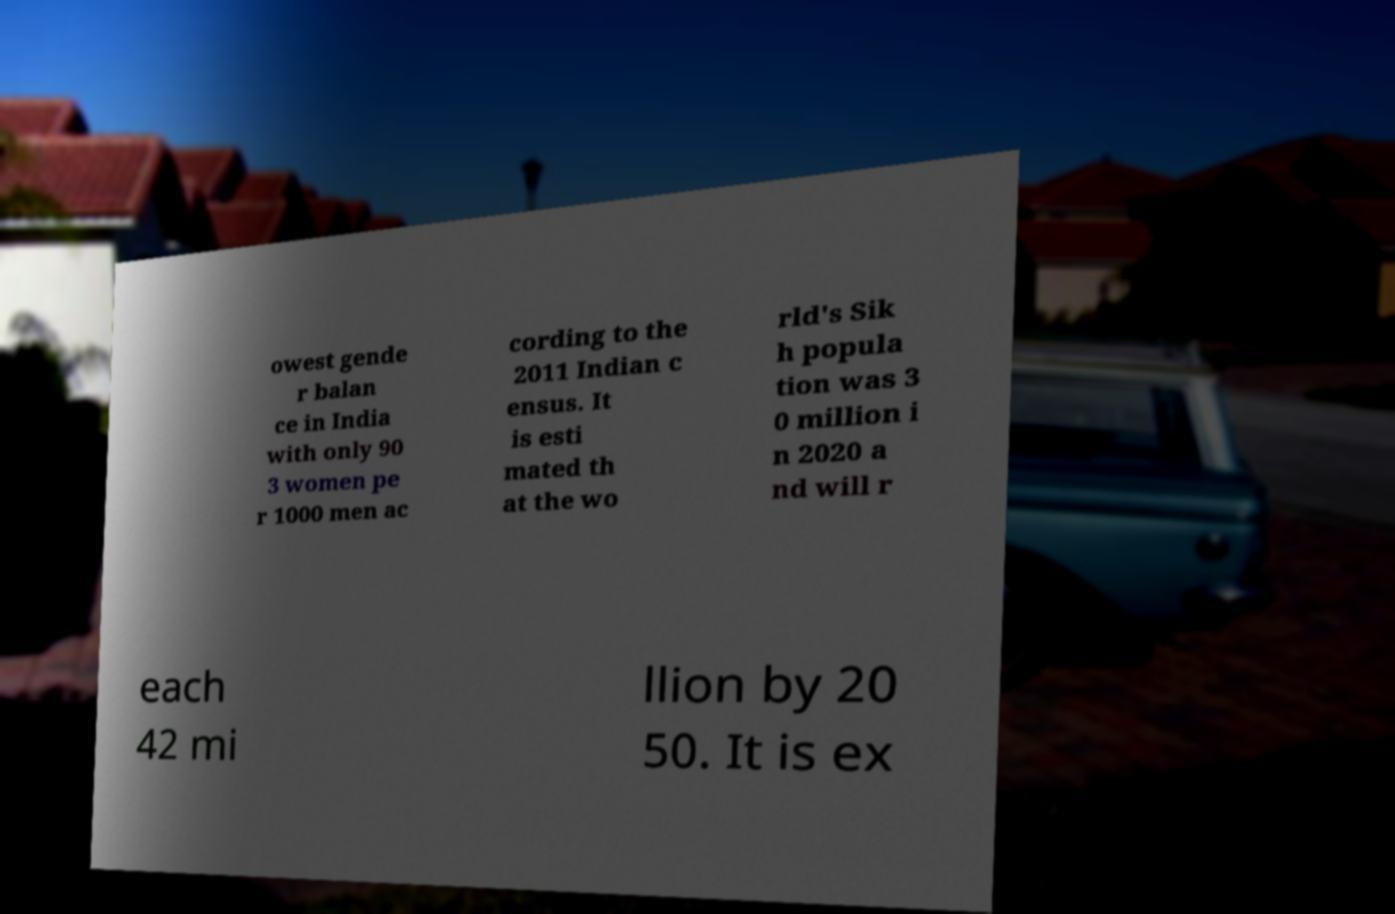Can you read and provide the text displayed in the image?This photo seems to have some interesting text. Can you extract and type it out for me? owest gende r balan ce in India with only 90 3 women pe r 1000 men ac cording to the 2011 Indian c ensus. It is esti mated th at the wo rld's Sik h popula tion was 3 0 million i n 2020 a nd will r each 42 mi llion by 20 50. It is ex 